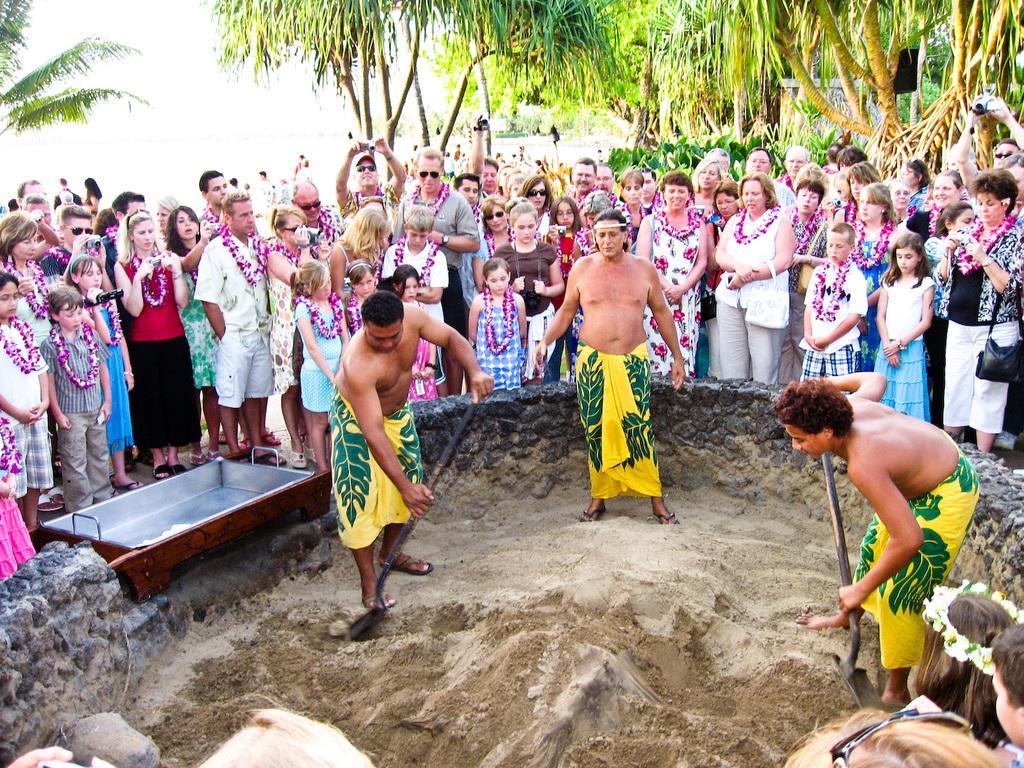In one or two sentences, can you explain what this image depicts? In this image we can see so many people are standing and holding some objects, two people are digging. The small rock wall is there, so many trees and one object on the surface. At the top there is the sky. 